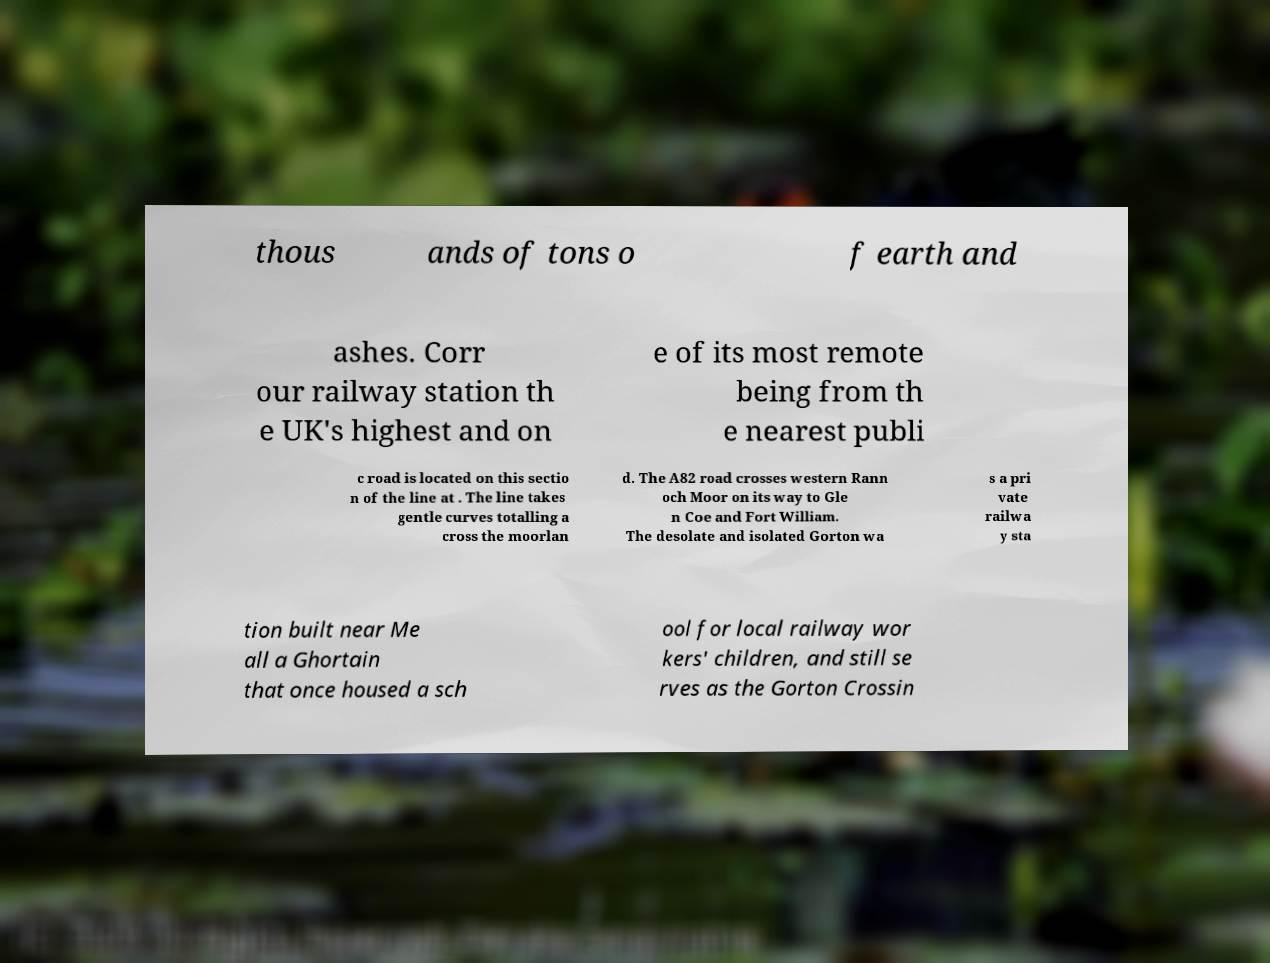Can you accurately transcribe the text from the provided image for me? thous ands of tons o f earth and ashes. Corr our railway station th e UK's highest and on e of its most remote being from th e nearest publi c road is located on this sectio n of the line at . The line takes gentle curves totalling a cross the moorlan d. The A82 road crosses western Rann och Moor on its way to Gle n Coe and Fort William. The desolate and isolated Gorton wa s a pri vate railwa y sta tion built near Me all a Ghortain that once housed a sch ool for local railway wor kers' children, and still se rves as the Gorton Crossin 